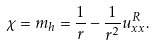Convert formula to latex. <formula><loc_0><loc_0><loc_500><loc_500>\chi = m _ { h } = \frac { 1 } { r } - \frac { 1 } { r ^ { 2 } } u _ { x x } ^ { R } .</formula> 